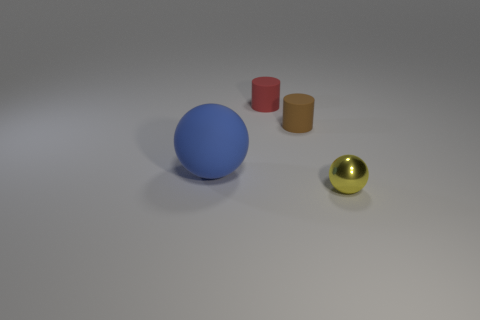Subtract all brown cylinders. How many cylinders are left? 1 Add 4 small yellow shiny cylinders. How many objects exist? 8 Subtract 1 cylinders. How many cylinders are left? 1 Add 4 blue objects. How many blue objects exist? 5 Subtract 1 blue spheres. How many objects are left? 3 Subtract all cyan spheres. Subtract all purple blocks. How many spheres are left? 2 Subtract all purple cylinders. How many blue balls are left? 1 Subtract all small brown cylinders. Subtract all matte cylinders. How many objects are left? 1 Add 4 tiny red cylinders. How many tiny red cylinders are left? 5 